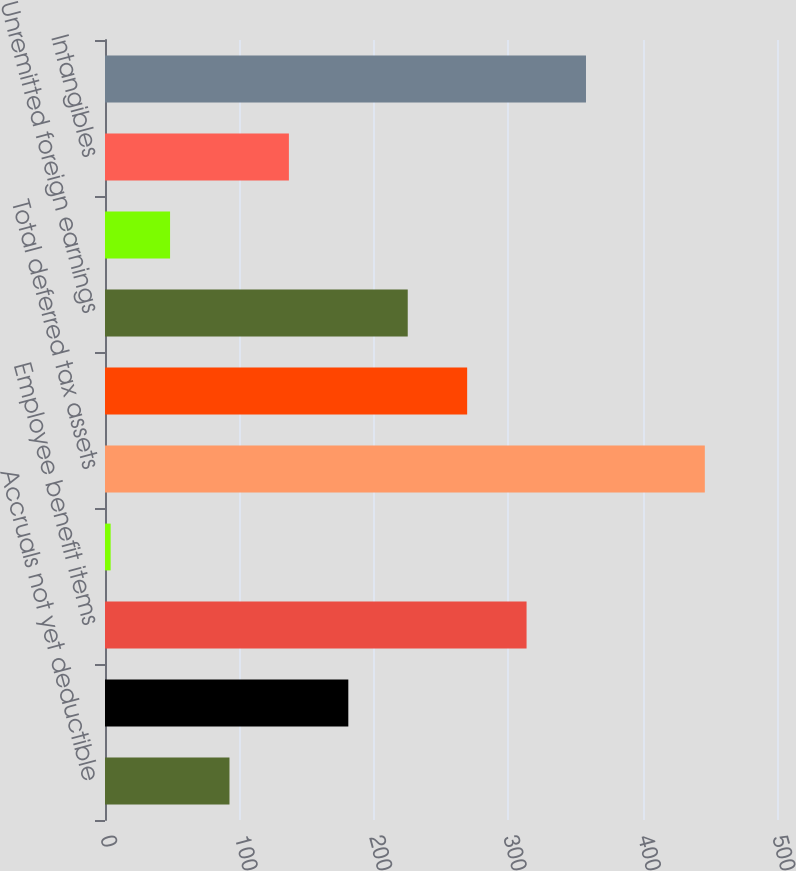Convert chart to OTSL. <chart><loc_0><loc_0><loc_500><loc_500><bar_chart><fcel>Accruals not yet deductible<fcel>Foreign net operating loss<fcel>Employee benefit items<fcel>Other<fcel>Total deferred tax assets<fcel>Depreciation and amortization<fcel>Unremitted foreign earnings<fcel>Inventories<fcel>Intangibles<fcel>Total deferred tax liabilities<nl><fcel>92.62<fcel>181.04<fcel>313.67<fcel>4.2<fcel>446.3<fcel>269.46<fcel>225.25<fcel>48.41<fcel>136.83<fcel>357.88<nl></chart> 